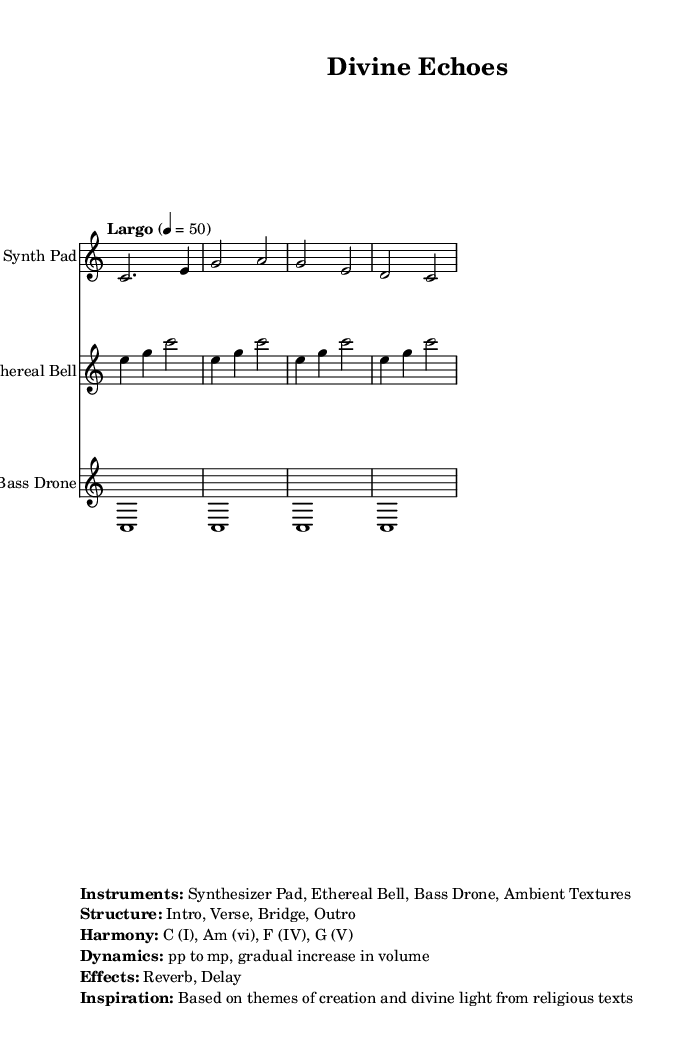What is the key signature of this music? The key signature is indicated in the header of the music, which shows C major. C major has no sharps or flats in its key signature.
Answer: C major What is the time signature of this piece? The time signature is shown at the beginning of the piece, which is 4/4. This means there are four beats in each measure and a quarter note gets one beat.
Answer: 4/4 What is the tempo marking for this composition? The tempo is indicated in the score with the word "Largo" and a metronome marking of 50. "Largo" suggests a slow tempo.
Answer: 50 What is the structure of the music? The structure is provided in the markup section, listing the components as Intro, Verse, Bridge, and Outro. These terms outline how the music is organized.
Answer: Intro, Verse, Bridge, Outro How many instruments are used in this piece? There are four instruments mentioned in the markup: Synth Pad, Ethereal Bell, Bass Drone, and Ambient Textures, which indicates the variety of sounds in this ambient electronic piece.
Answer: Four Which musical harmony is primarily used in this piece? The harmony provided in the markup includes the chords C (I), Am (vi), F (IV), and G (V), which are common in many musical compositions, particularly in ambient music to create a lush sound.
Answer: C, Am, F, G What effects are applied in this composition? The effects mentioned in the markup section are Reverb and Delay, which are typical in electronic music to create ambient soundscapes and enhance the feeling of space.
Answer: Reverb, Delay 